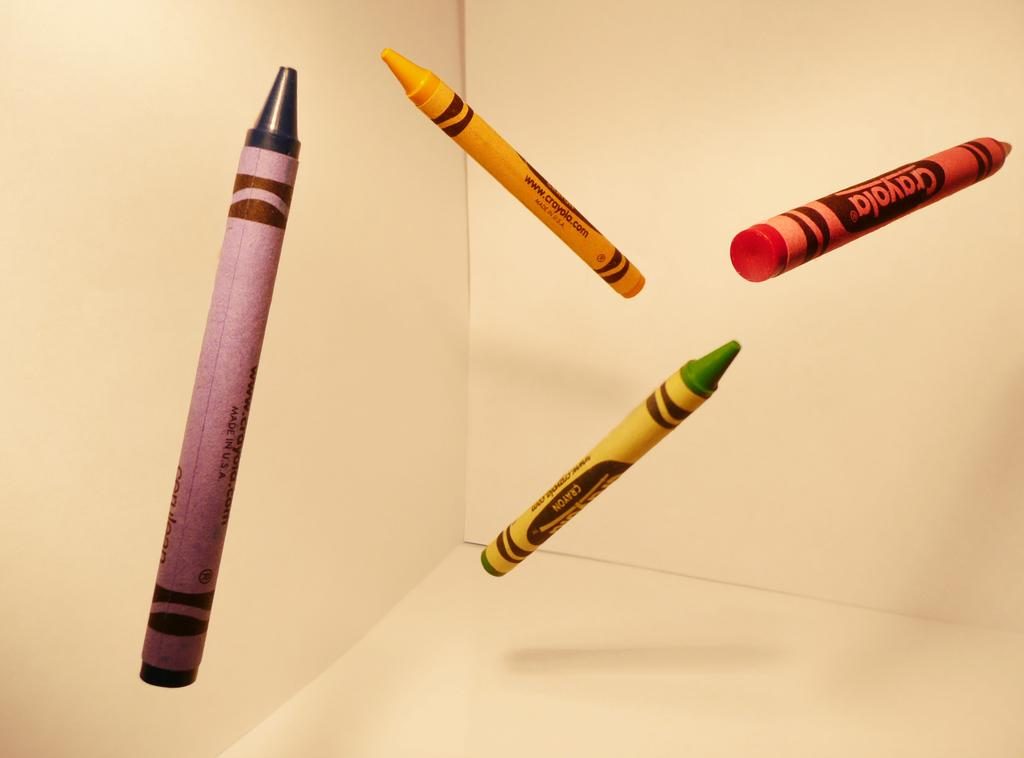What type of objects are visible in the image? There are colorful crayons in the image. How are the crayons positioned in the image? The crayons appear to be in the air. What is the background color of the image? The remaining portion of the image is in cream color. Are there any dinosaurs visible in the image? No, there are no dinosaurs present in the image. Can you see any houses in the image? No, there are no houses visible in the image. 